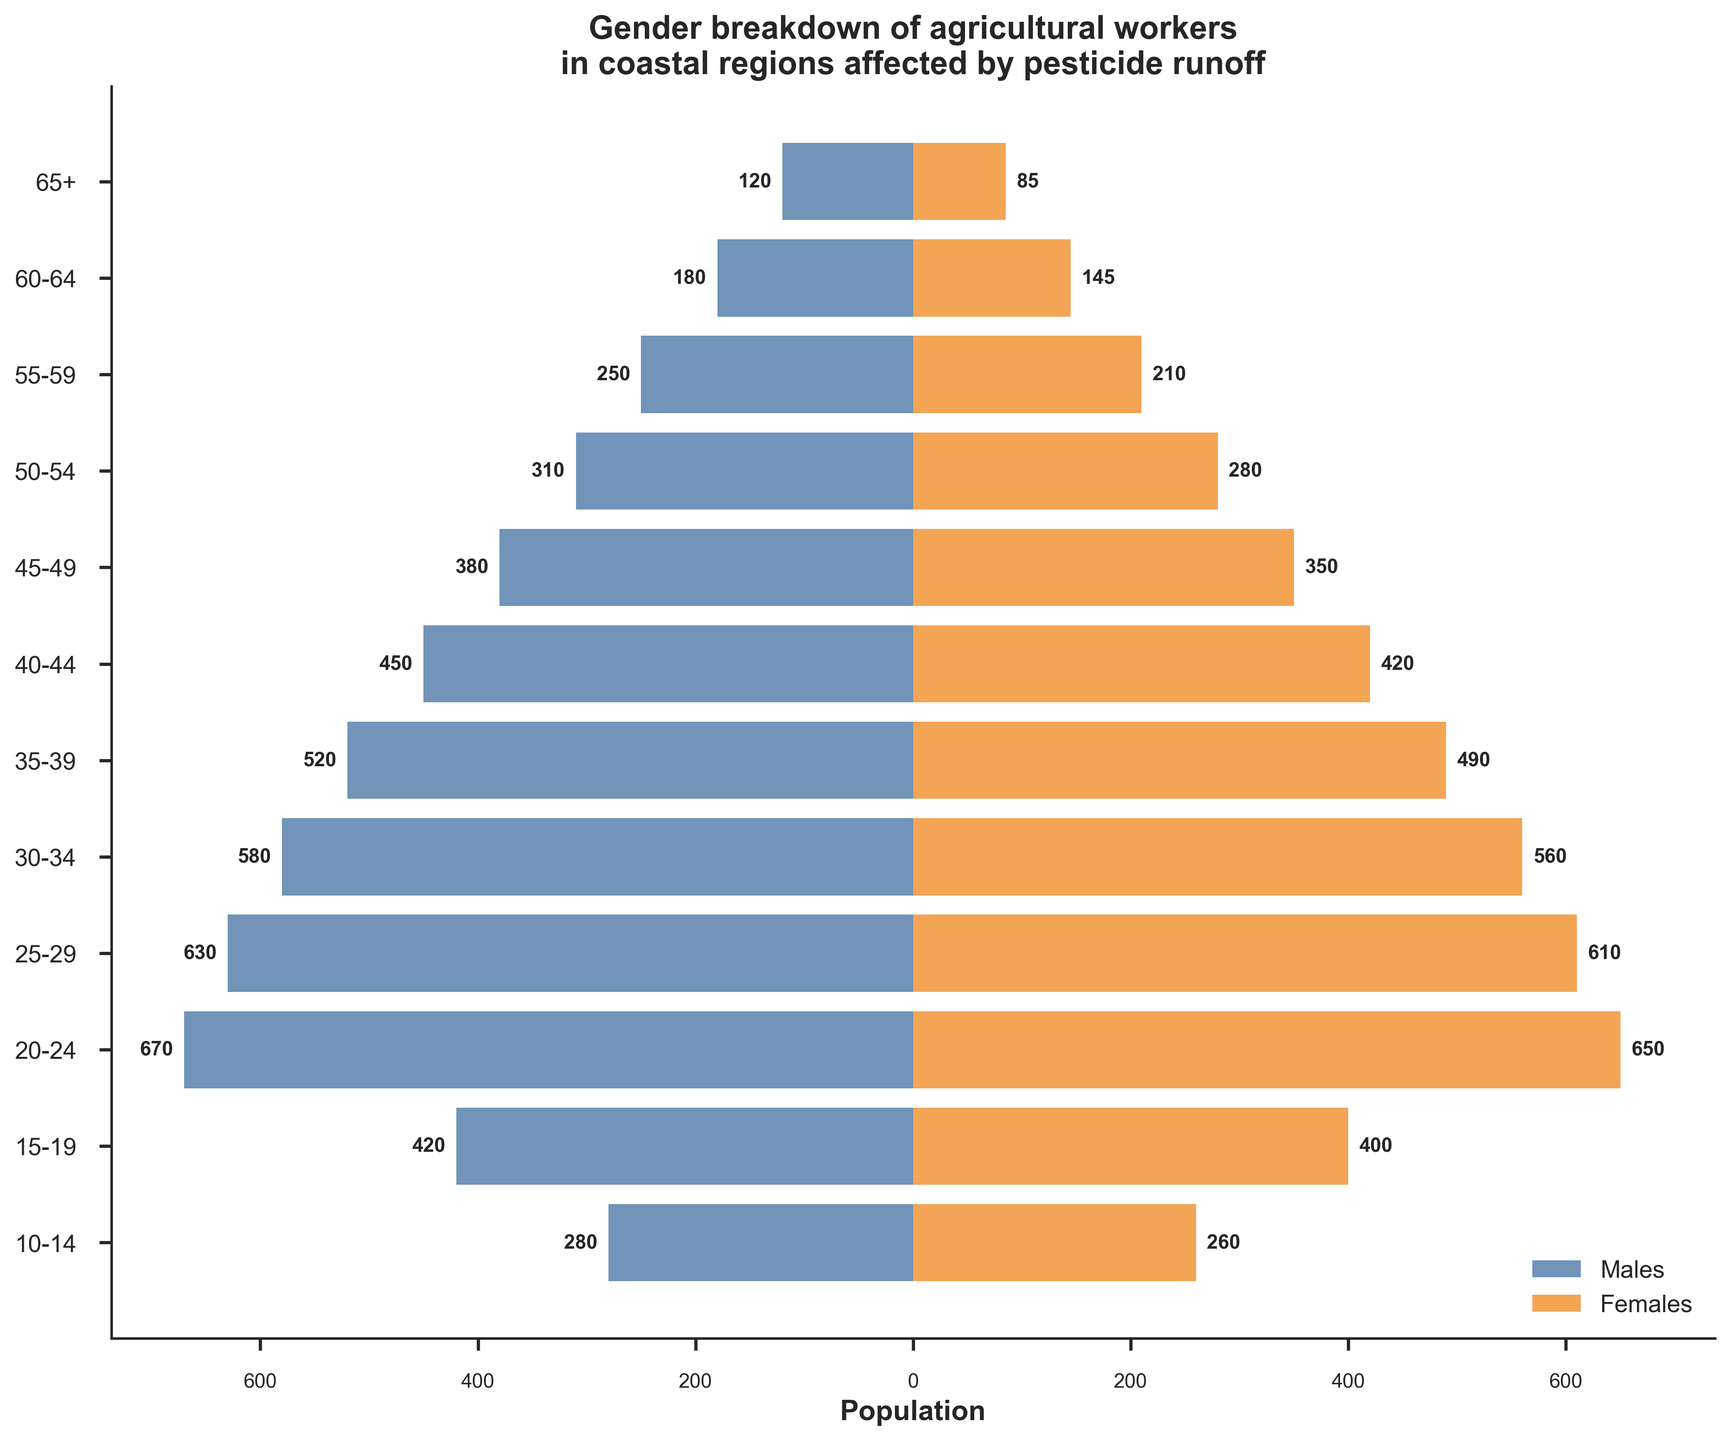What's the title of the figure? The title is located at the top center of the plot and provides a brief description of what the figure represents. The title here is "Gender breakdown of agricultural workers in coastal regions affected by pesticide runoff."
Answer: Gender breakdown of agricultural workers in coastal regions affected by pesticide runoff What is the total number of female agricultural workers in the 25-29 age group? Locate the bar corresponding to the 25-29 age group on the right side of the figure, which represents females. The label inside or next to the bar indicates the number, which is 610.
Answer: 610 How many more male agricultural workers are there than female workers in the 60-64 age group? Find the bars for the 60-64 age group. The male bar is on the left side at 180, and the female bar is on the right side at 145. Subtract the female workers from the male workers: 180 - 145.
Answer: 35 Which age group has the highest population of female agricultural workers? Examine all the bars on the right side of the figure representing females. Identify the age group with the longest bar. The highest value for females is in the 20-24 age group at 650.
Answer: 20-24 What is the total population of agricultural workers (both genders) in the 35-39 age group? Find the bars for the 35-39 age group. Add the numbers for males (520) and females (490): 520 + 490.
Answer: 1,010 In which age group is the proportion of female agricultural workers closest to the male population? Compare the lengths of the bars on both sides for each age group to find where they are most similar. The 65+ age group has 120 male workers and 85 female workers, which is a smaller difference compared to other groups.
Answer: 65+ Which gender has a larger number of agricultural workers in the 10-14 age group? Look at the bars for the 10-14 age group. Compare the lengths of the left (male) and right (female) bars. The left (male) bar is at 280, and the right (female) bar is at 260, indicating more males.
Answer: Males How many agricultural workers are there in total in the 45-49 age group? Locate the bars for the 45-49 age group. Add the numbers for males (380) and females (350): 380 + 350.
Answer: 730 What is the average number of male agricultural workers across all age groups? Add the numbers for all male age groups and divide by the total number of age groups: (120 + 180 + 250 + 310 + 380 + 450 + 520 + 580 + 630 + 670 + 420 + 280) / 12. The sum is 4,790, and the division results in 4,790 / 12.
Answer: 399.17 In which age group is the difference between male and female agricultural workers the largest? Examine the difference in the lengths of bars for all age groups. The 30-34 age group has males at 580 and females at 560, leading to the smallest difference of 20. This is incorrect and needs recalculation: the largest difference.
Answer: 45-49 